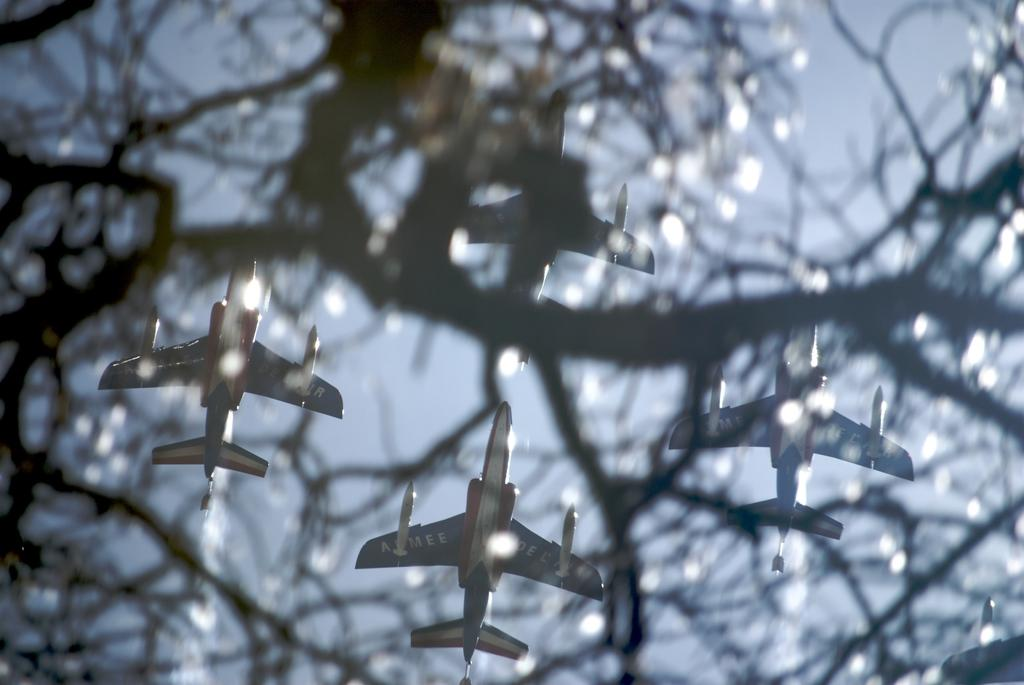What is located in the foreground of the image? There is a tree in the foreground of the image. What is happening in the background of the image? Jet planes are moving in the air in the background of the image. What can be seen in the sky in the image? The sky is visible in the background of the image. Can you see any snails crawling on the tree in the image? There are no snails visible on the tree in the image. What is the sister of the person taking the image doing in the background? There is no person taking the image, and no sister is mentioned in the provided facts. 